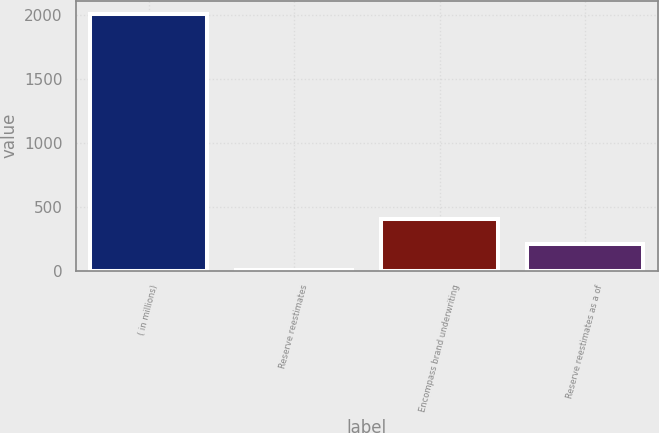Convert chart to OTSL. <chart><loc_0><loc_0><loc_500><loc_500><bar_chart><fcel>( in millions)<fcel>Reserve reestimates<fcel>Encompass brand underwriting<fcel>Reserve reestimates as a of<nl><fcel>2010<fcel>6<fcel>406.8<fcel>206.4<nl></chart> 